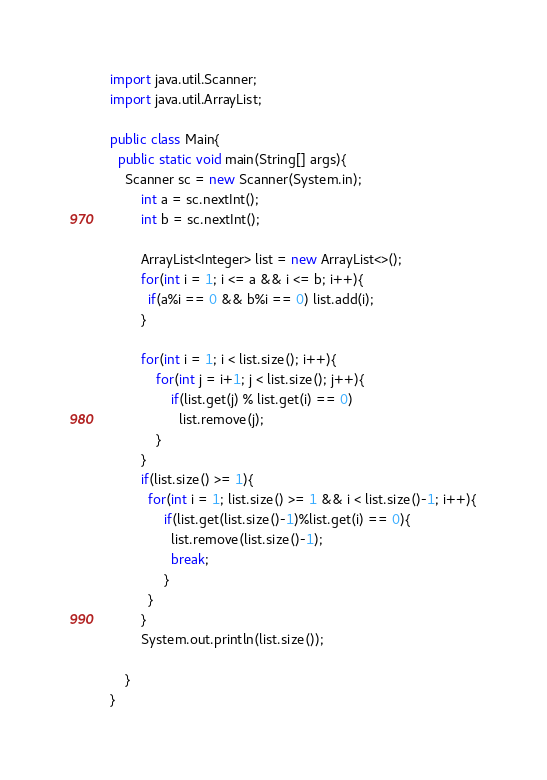Convert code to text. <code><loc_0><loc_0><loc_500><loc_500><_Java_>import java.util.Scanner;
import java.util.ArrayList;

public class Main{
  public static void main(String[] args){
    Scanner sc = new Scanner(System.in);
        int a = sc.nextInt();
        int b = sc.nextInt();

    	ArrayList<Integer> list = new ArrayList<>();
        for(int i = 1; i <= a && i <= b; i++){
          if(a%i == 0 && b%i == 0) list.add(i);
        }
    
        for(int i = 1; i < list.size(); i++){
        	for(int j = i+1; j < list.size(); j++){
            	if(list.get(j) % list.get(i) == 0)
                  list.remove(j);
            }
        }
    	if(list.size() >= 1){
          for(int i = 1; list.size() >= 1 && i < list.size()-1; i++){
              if(list.get(list.size()-1)%list.get(i) == 0){
                list.remove(list.size()-1);
                break;
              }
          }
        }
      	System.out.println(list.size());

    }
}</code> 